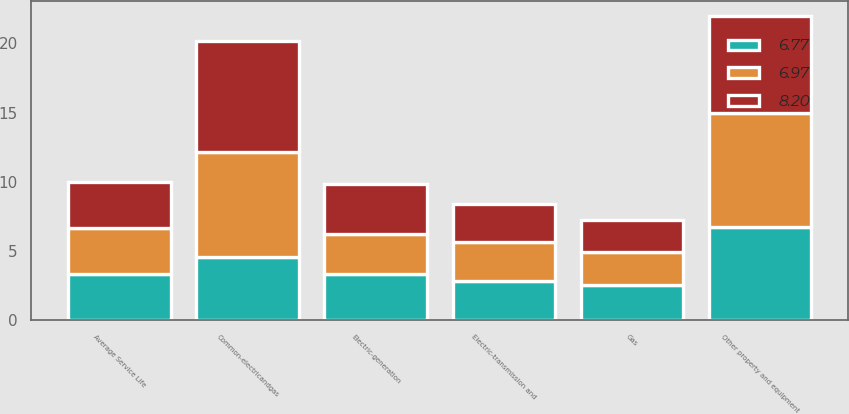Convert chart to OTSL. <chart><loc_0><loc_0><loc_500><loc_500><stacked_bar_chart><ecel><fcel>Average Service Life<fcel>Electric-transmission and<fcel>Electric-generation<fcel>Gas<fcel>Common-electricandgas<fcel>Other property and equipment<nl><fcel>8.2<fcel>3.34<fcel>2.79<fcel>3.59<fcel>2.32<fcel>8.06<fcel>6.97<nl><fcel>6.77<fcel>3.34<fcel>2.82<fcel>3.34<fcel>2.52<fcel>4.6<fcel>6.77<nl><fcel>6.97<fcel>3.34<fcel>2.81<fcel>2.9<fcel>2.38<fcel>7.53<fcel>8.2<nl></chart> 